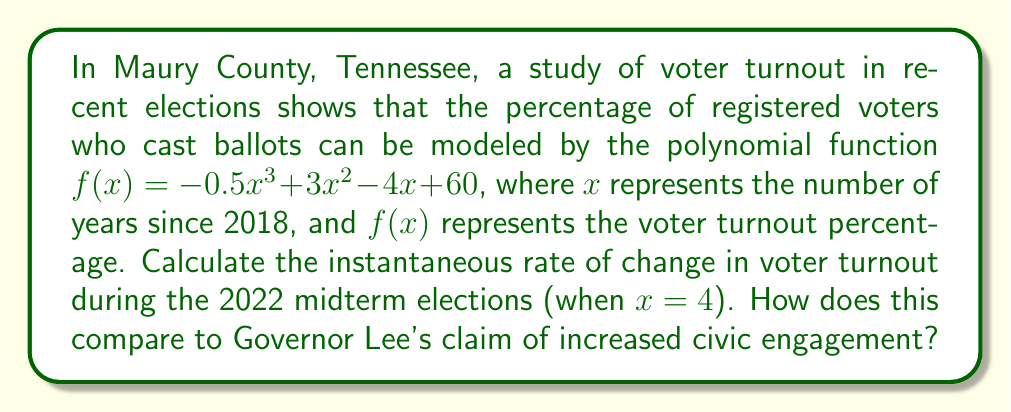What is the answer to this math problem? To find the instantaneous rate of change at $x = 4$, we need to calculate the derivative of the function $f(x)$ and evaluate it at $x = 4$.

Step 1: Find the derivative of $f(x)$
$$f(x) = -0.5x^3 + 3x^2 - 4x + 60$$
$$f'(x) = -1.5x^2 + 6x - 4$$

Step 2: Evaluate $f'(x)$ at $x = 4$
$$f'(4) = -1.5(4)^2 + 6(4) - 4$$
$$f'(4) = -1.5(16) + 24 - 4$$
$$f'(4) = -24 + 24 - 4$$
$$f'(4) = -4$$

The instantaneous rate of change at $x = 4$ is -4 percentage points per year. This negative value indicates that voter turnout was decreasing at the time of the 2022 midterm elections, contradicting any claims of increased civic engagement.
Answer: $-4$ percentage points per year 